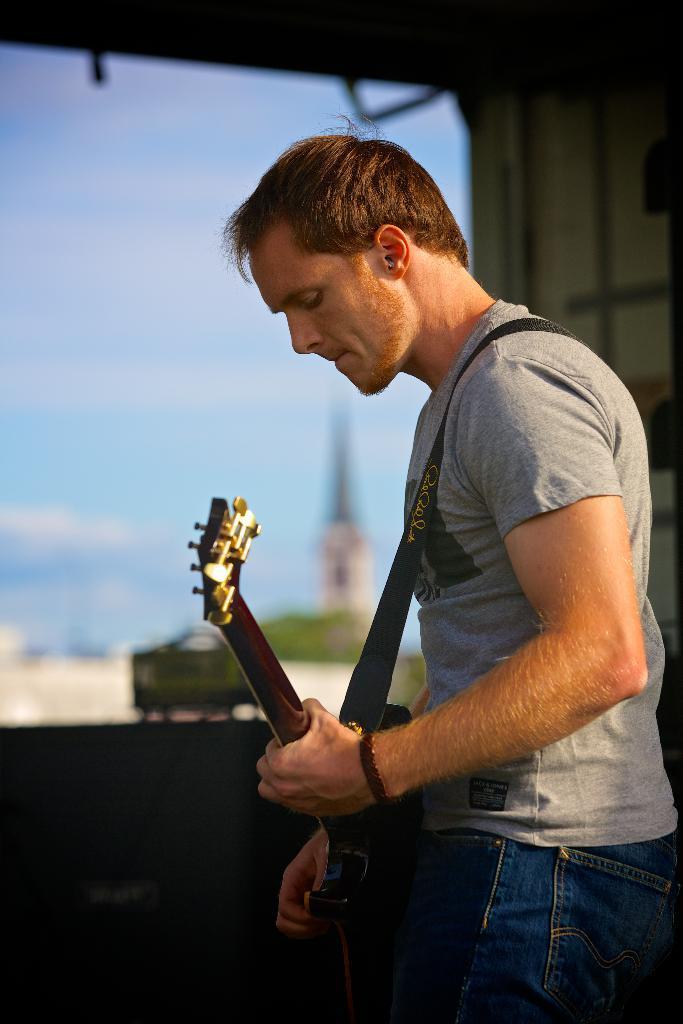How would you summarize this image in a sentence or two? In this image there is a man standing and playing a guitar and the back ground there is a plants , sky. 